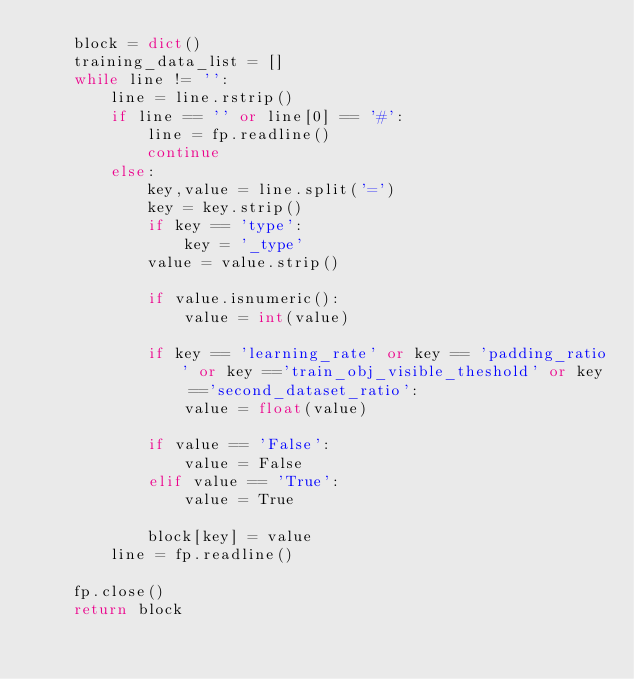<code> <loc_0><loc_0><loc_500><loc_500><_Python_>    block = dict()
    training_data_list = []
    while line != '':
        line = line.rstrip()
        if line == '' or line[0] == '#':
            line = fp.readline()
            continue        
        else:
            key,value = line.split('=')
            key = key.strip()
            if key == 'type':
                key = '_type'
            value = value.strip()

            if value.isnumeric():
                value = int(value)

            if key == 'learning_rate' or key == 'padding_ratio' or key =='train_obj_visible_theshold' or key =='second_dataset_ratio':
                value = float(value)

            if value == 'False':
                value = False
            elif value == 'True':
                value = True
                
            block[key] = value
        line = fp.readline()

    fp.close()
    return block</code> 